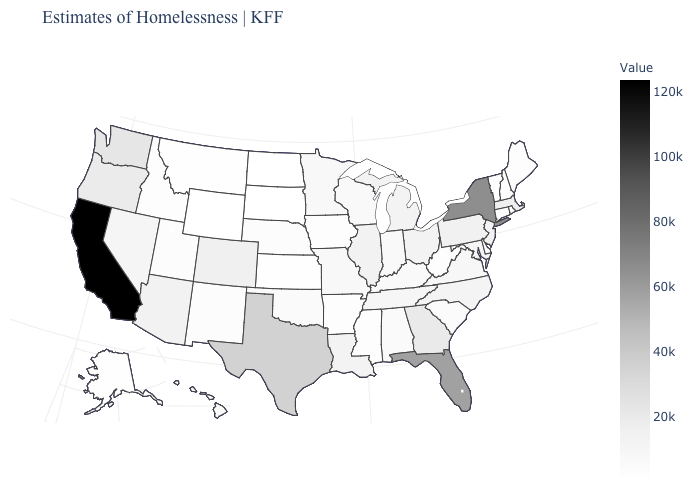Which states hav the highest value in the West?
Keep it brief. California. Among the states that border Tennessee , which have the highest value?
Keep it brief. Georgia. Does the map have missing data?
Keep it brief. No. Does the map have missing data?
Answer briefly. No. Among the states that border Mississippi , does Tennessee have the lowest value?
Quick response, please. No. 